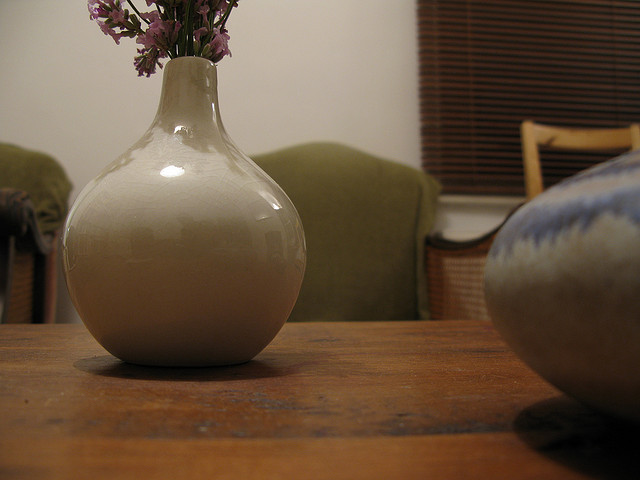<image>When were the flowers in the vase watered last? It is unknown when the flowers in the vase were last watered. When were the flowers in the vase watered last? I am not sure when the flowers in the vase were watered last. It can be seen that they were watered recently, yesterday, today, or 3 weeks ago. 